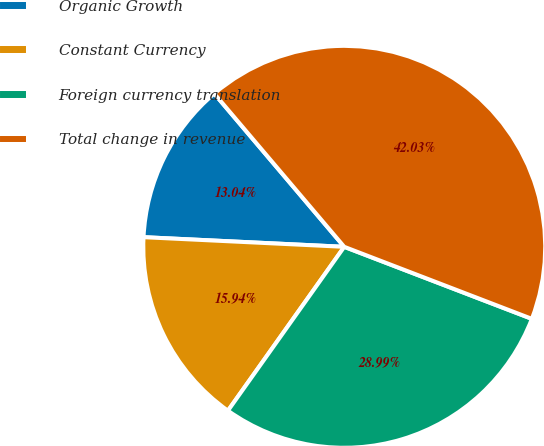Convert chart to OTSL. <chart><loc_0><loc_0><loc_500><loc_500><pie_chart><fcel>Organic Growth<fcel>Constant Currency<fcel>Foreign currency translation<fcel>Total change in revenue<nl><fcel>13.04%<fcel>15.94%<fcel>28.99%<fcel>42.03%<nl></chart> 